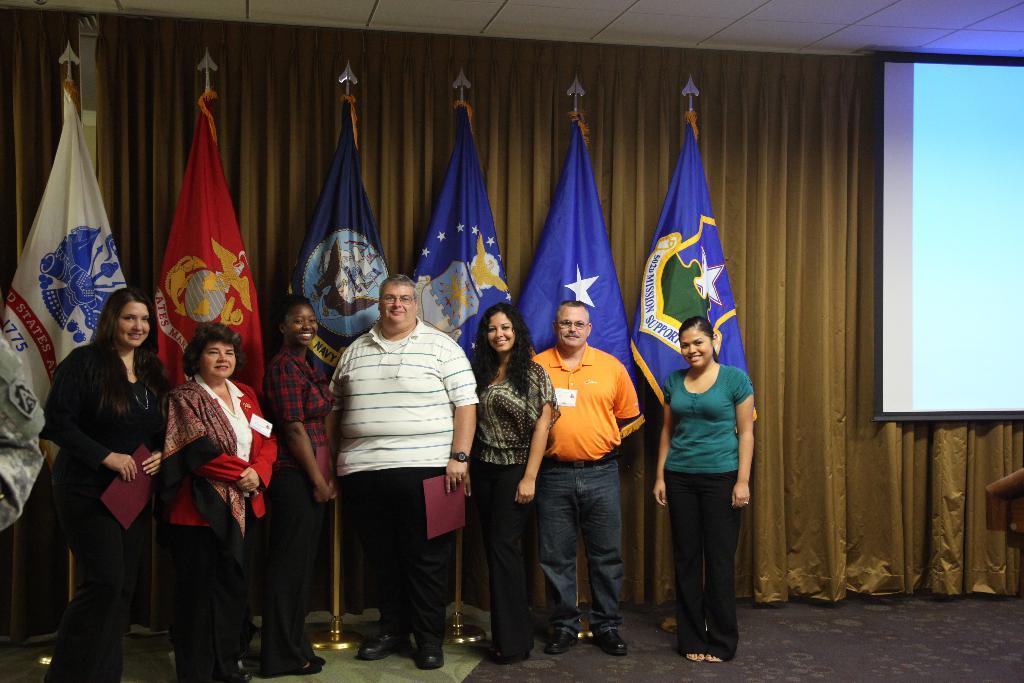Can you describe this image briefly? In the picture I can see people are standing among them some are holding objects in hands. These people are smiling. In the background I can see curtains, a projector screen and the ceiling. 